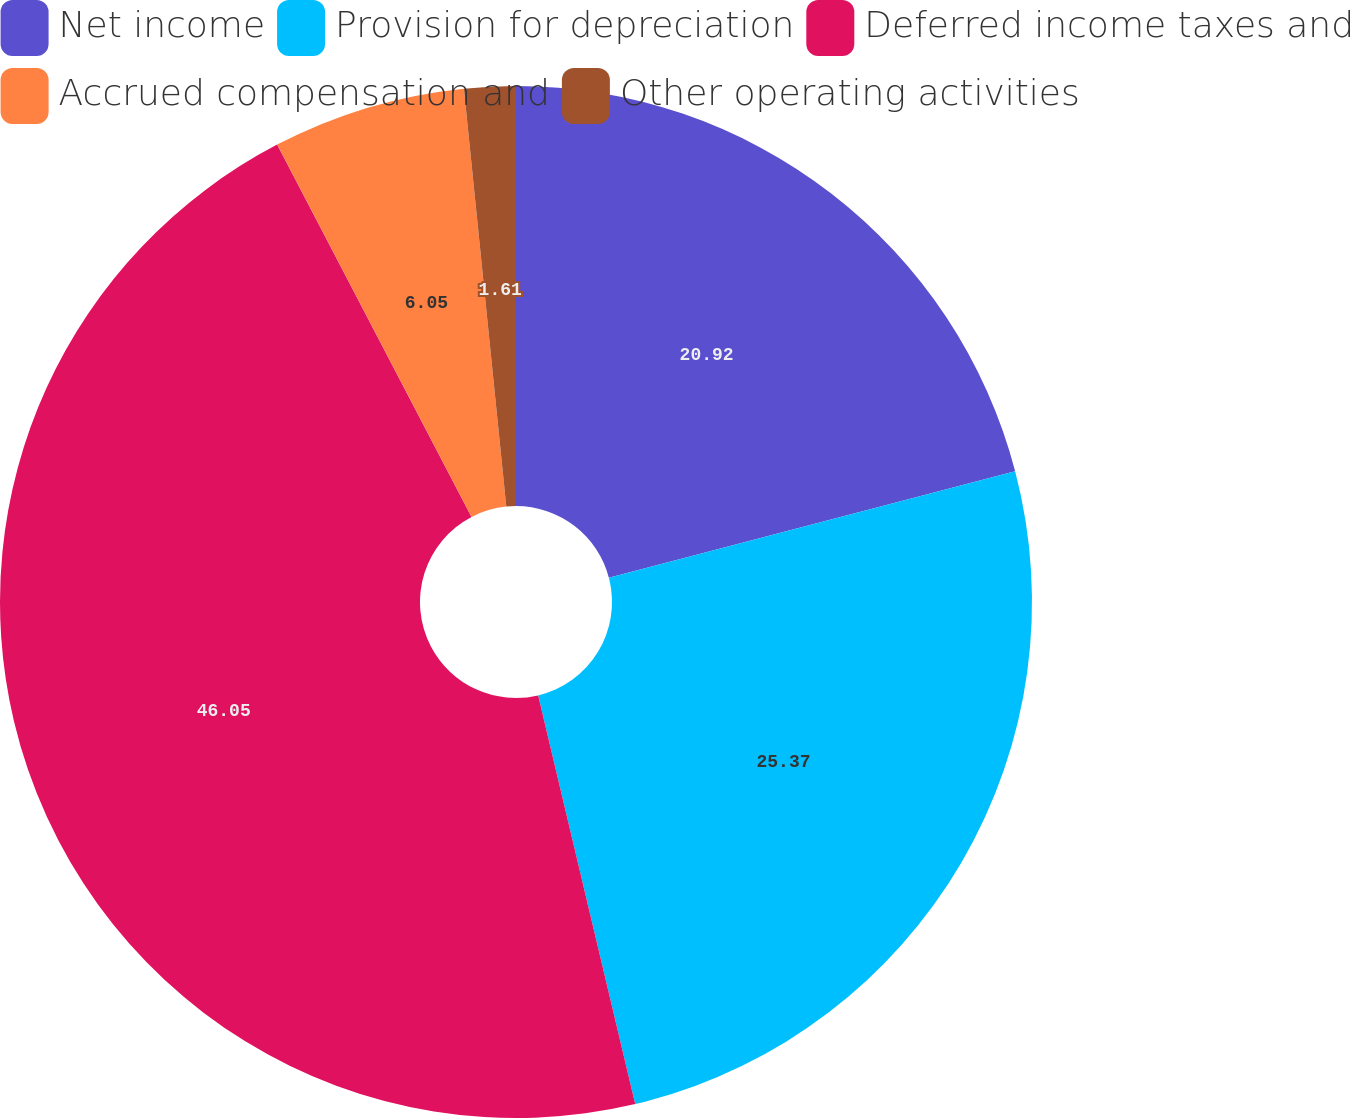<chart> <loc_0><loc_0><loc_500><loc_500><pie_chart><fcel>Net income<fcel>Provision for depreciation<fcel>Deferred income taxes and<fcel>Accrued compensation and<fcel>Other operating activities<nl><fcel>20.92%<fcel>25.37%<fcel>46.05%<fcel>6.05%<fcel>1.61%<nl></chart> 